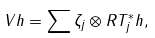<formula> <loc_0><loc_0><loc_500><loc_500>V h = \sum \zeta _ { j } \otimes R T _ { j } ^ { * } h ,</formula> 